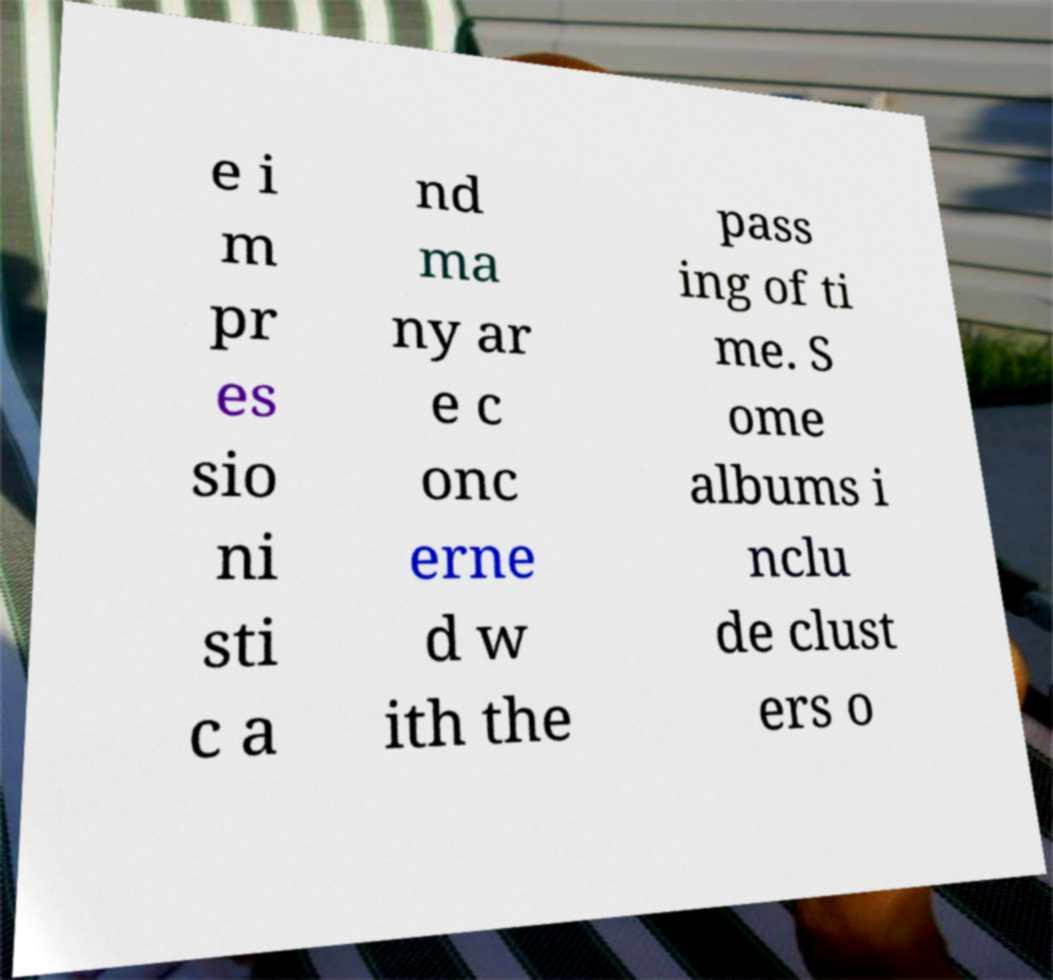Can you read and provide the text displayed in the image?This photo seems to have some interesting text. Can you extract and type it out for me? e i m pr es sio ni sti c a nd ma ny ar e c onc erne d w ith the pass ing of ti me. S ome albums i nclu de clust ers o 